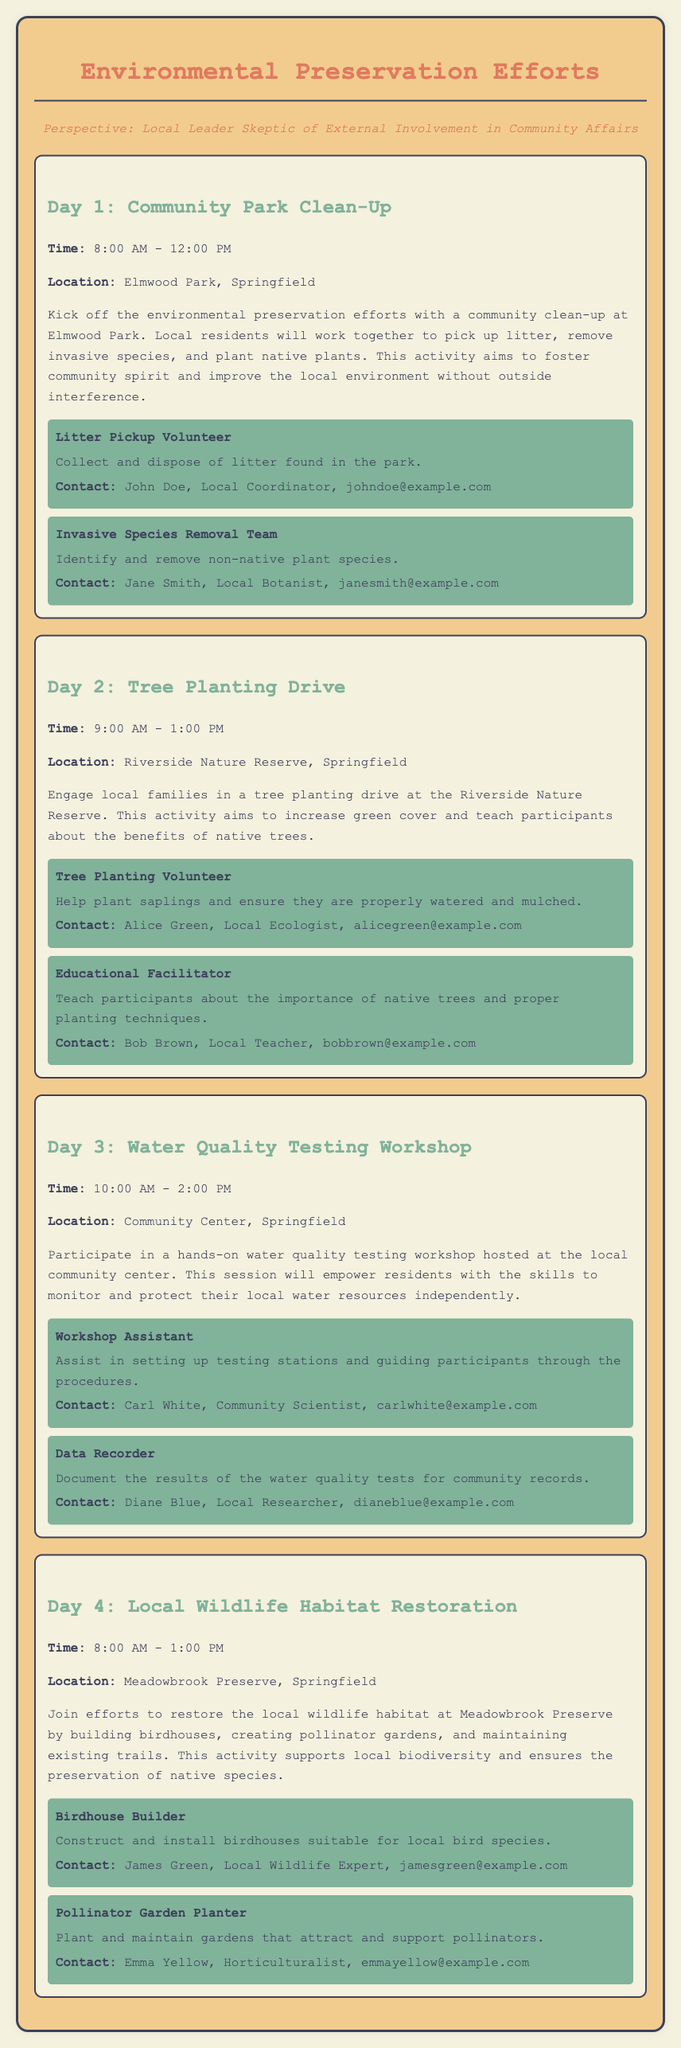What is the title of the document? The title of the document is presented at the top.
Answer: Environmental Preservation Efforts What is the location for Day 1 activities? The location is specified under the Day 1 section.
Answer: Elmwood Park, Springfield Who is the local coordinator for the litter pickup volunteer opportunity? The coordinator's name and contact information are listed in the volunteer opportunity section for Day 1.
Answer: John Doe What time does the tree planting drive start? The starting time is mentioned in the Day 2 section.
Answer: 9:00 AM How many days are covered in the itinerary? The itinerary lists activities for each day, which can be counted.
Answer: 4 Which activity involves water quality testing? The specific day section for this activity includes the title.
Answer: Day 3: Water Quality Testing Workshop What kind of expertise does Bob Brown possess? Bob Brown's designation is mentioned in the Day 2 volunteer opportunity section.
Answer: Local Teacher What will participants learn about on Day 2? The purpose of the Day 2 activity is outlined in the description.
Answer: Importance of native trees What activity will take place at Meadowbrook Preserve? The planned activity is described in Day 4's section.
Answer: Local Wildlife Habitat Restoration 